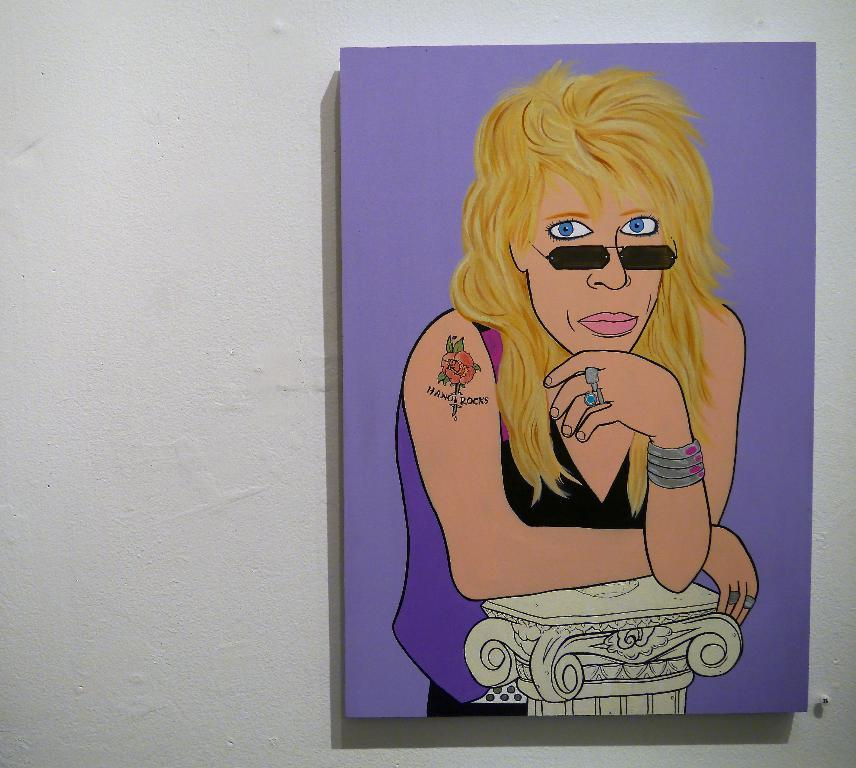What type of person can be seen in the image? There is a human in the image. What object is present in the image alongside the human? There is a board in the image. What is depicted on the board? The board has a painting on it. Where is the board located in the image? The board is on a white wall. How many bells are hanging from the leg of the human in the image? There are no bells or legs mentioned in the image; it only features a human, a board, and a painting. 